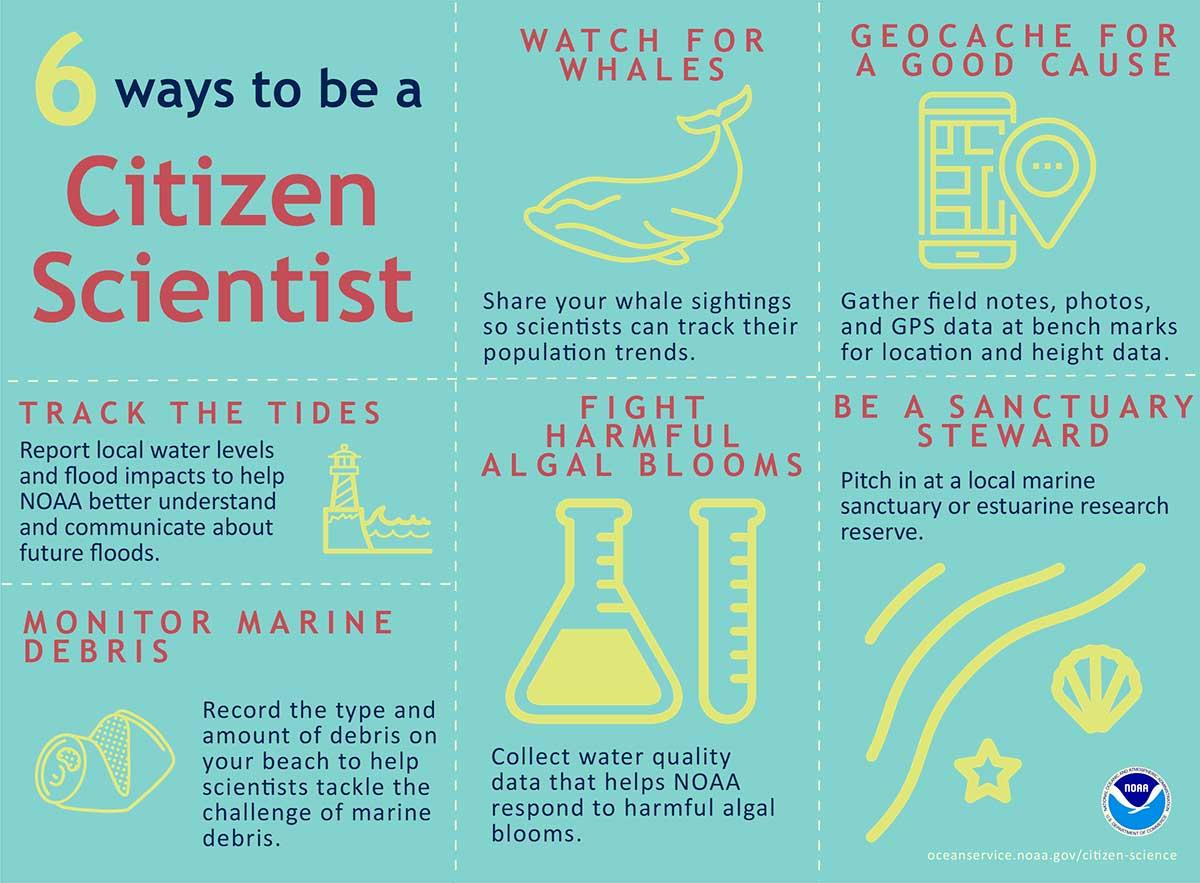Specify some key components in this picture. NOAA responds to harmful algal blooms through the use of water quality data, which provides critical information for understanding and mitigating the impacts of these blooms. We can use a variety of tools and methods to track the tides and monitor local water levels, including satellite imagery, sensors, and weather forecasts. This information can be used to inform decisions related to flood prevention and management, and to help communities plan for and respond to potential flood events. As a sanctuary steward, I would contribute to the protection and preservation of marine sanctuaries and estuarine research reserves by volunteering my time and effort to support the conservation efforts of these important ecosystems. 